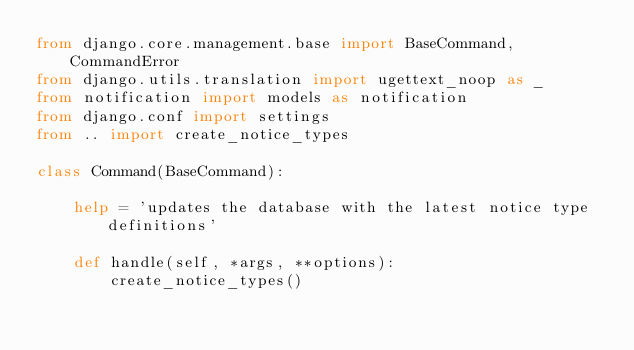<code> <loc_0><loc_0><loc_500><loc_500><_Python_>from django.core.management.base import BaseCommand, CommandError
from django.utils.translation import ugettext_noop as _
from notification import models as notification
from django.conf import settings
from .. import create_notice_types

class Command(BaseCommand):

    help = 'updates the database with the latest notice type definitions'
  
    def handle(self, *args, **options):
        create_notice_types()
        
        
        
        
        
        
</code> 